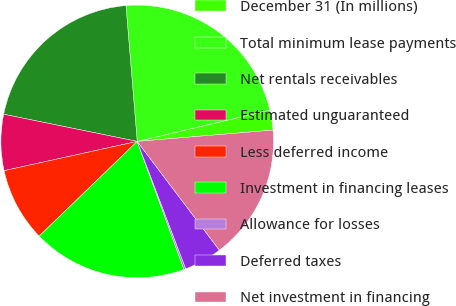<chart> <loc_0><loc_0><loc_500><loc_500><pie_chart><fcel>December 31 (In millions)<fcel>Total minimum lease payments<fcel>Net rentals receivables<fcel>Estimated unguaranteed<fcel>Less deferred income<fcel>Investment in financing leases<fcel>Allowance for losses<fcel>Deferred taxes<fcel>Net investment in financing<nl><fcel>2.36%<fcel>22.63%<fcel>20.49%<fcel>6.64%<fcel>8.78%<fcel>18.35%<fcel>0.22%<fcel>4.5%<fcel>16.03%<nl></chart> 